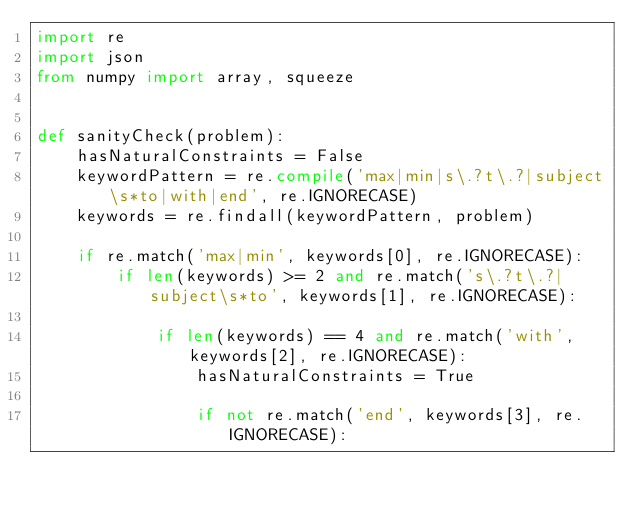Convert code to text. <code><loc_0><loc_0><loc_500><loc_500><_Python_>import re
import json
from numpy import array, squeeze


def sanityCheck(problem):
    hasNaturalConstraints = False
    keywordPattern = re.compile('max|min|s\.?t\.?|subject\s*to|with|end', re.IGNORECASE)
    keywords = re.findall(keywordPattern, problem)

    if re.match('max|min', keywords[0], re.IGNORECASE):
        if len(keywords) >= 2 and re.match('s\.?t\.?|subject\s*to', keywords[1], re.IGNORECASE):

            if len(keywords) == 4 and re.match('with', keywords[2], re.IGNORECASE):
                hasNaturalConstraints = True
                    
                if not re.match('end', keywords[3], re.IGNORECASE):</code> 